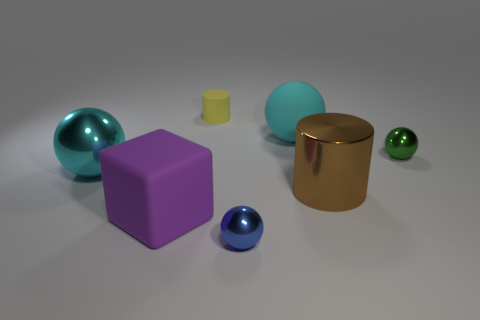Add 1 big brown things. How many objects exist? 8 Subtract all shiny balls. How many balls are left? 1 Subtract all yellow cylinders. How many cylinders are left? 1 Subtract 1 balls. How many balls are left? 3 Subtract all brown spheres. Subtract all red cylinders. How many spheres are left? 4 Subtract all red blocks. How many gray cylinders are left? 0 Subtract all small blue metal balls. Subtract all large yellow rubber objects. How many objects are left? 6 Add 4 tiny objects. How many tiny objects are left? 7 Add 5 large cyan balls. How many large cyan balls exist? 7 Subtract 0 green cubes. How many objects are left? 7 